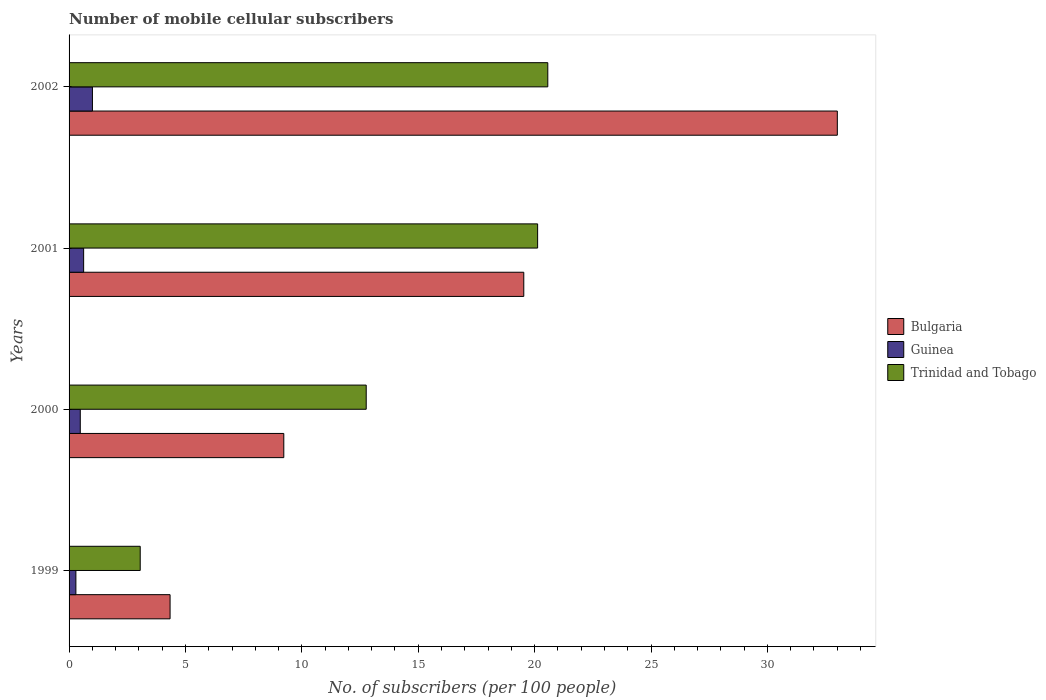How many different coloured bars are there?
Ensure brevity in your answer.  3. How many bars are there on the 3rd tick from the top?
Your answer should be very brief. 3. How many bars are there on the 4th tick from the bottom?
Provide a short and direct response. 3. In how many cases, is the number of bars for a given year not equal to the number of legend labels?
Your answer should be compact. 0. What is the number of mobile cellular subscribers in Bulgaria in 2000?
Provide a short and direct response. 9.22. Across all years, what is the maximum number of mobile cellular subscribers in Guinea?
Offer a terse response. 1. Across all years, what is the minimum number of mobile cellular subscribers in Guinea?
Your answer should be very brief. 0.29. What is the total number of mobile cellular subscribers in Guinea in the graph?
Give a very brief answer. 2.4. What is the difference between the number of mobile cellular subscribers in Trinidad and Tobago in 2000 and that in 2001?
Provide a short and direct response. -7.36. What is the difference between the number of mobile cellular subscribers in Trinidad and Tobago in 2001 and the number of mobile cellular subscribers in Bulgaria in 2002?
Your answer should be compact. -12.88. What is the average number of mobile cellular subscribers in Trinidad and Tobago per year?
Keep it short and to the point. 14.13. In the year 2002, what is the difference between the number of mobile cellular subscribers in Guinea and number of mobile cellular subscribers in Trinidad and Tobago?
Provide a succinct answer. -19.56. What is the ratio of the number of mobile cellular subscribers in Trinidad and Tobago in 1999 to that in 2002?
Provide a succinct answer. 0.15. What is the difference between the highest and the second highest number of mobile cellular subscribers in Guinea?
Provide a succinct answer. 0.38. What is the difference between the highest and the lowest number of mobile cellular subscribers in Trinidad and Tobago?
Make the answer very short. 17.51. In how many years, is the number of mobile cellular subscribers in Bulgaria greater than the average number of mobile cellular subscribers in Bulgaria taken over all years?
Keep it short and to the point. 2. What does the 2nd bar from the top in 2002 represents?
Make the answer very short. Guinea. What does the 2nd bar from the bottom in 2000 represents?
Make the answer very short. Guinea. Is it the case that in every year, the sum of the number of mobile cellular subscribers in Bulgaria and number of mobile cellular subscribers in Guinea is greater than the number of mobile cellular subscribers in Trinidad and Tobago?
Make the answer very short. No. How many bars are there?
Keep it short and to the point. 12. Are all the bars in the graph horizontal?
Your response must be concise. Yes. How many years are there in the graph?
Offer a very short reply. 4. What is the difference between two consecutive major ticks on the X-axis?
Keep it short and to the point. 5. Does the graph contain any zero values?
Your response must be concise. No. How many legend labels are there?
Your answer should be very brief. 3. How are the legend labels stacked?
Your answer should be very brief. Vertical. What is the title of the graph?
Make the answer very short. Number of mobile cellular subscribers. Does "Gabon" appear as one of the legend labels in the graph?
Offer a very short reply. No. What is the label or title of the X-axis?
Ensure brevity in your answer.  No. of subscribers (per 100 people). What is the label or title of the Y-axis?
Your answer should be compact. Years. What is the No. of subscribers (per 100 people) in Bulgaria in 1999?
Your answer should be compact. 4.34. What is the No. of subscribers (per 100 people) of Guinea in 1999?
Offer a very short reply. 0.29. What is the No. of subscribers (per 100 people) in Trinidad and Tobago in 1999?
Make the answer very short. 3.06. What is the No. of subscribers (per 100 people) of Bulgaria in 2000?
Your response must be concise. 9.22. What is the No. of subscribers (per 100 people) in Guinea in 2000?
Ensure brevity in your answer.  0.48. What is the No. of subscribers (per 100 people) in Trinidad and Tobago in 2000?
Make the answer very short. 12.77. What is the No. of subscribers (per 100 people) of Bulgaria in 2001?
Offer a terse response. 19.53. What is the No. of subscribers (per 100 people) in Guinea in 2001?
Provide a succinct answer. 0.63. What is the No. of subscribers (per 100 people) in Trinidad and Tobago in 2001?
Give a very brief answer. 20.13. What is the No. of subscribers (per 100 people) of Bulgaria in 2002?
Provide a succinct answer. 33. What is the No. of subscribers (per 100 people) of Guinea in 2002?
Provide a short and direct response. 1. What is the No. of subscribers (per 100 people) in Trinidad and Tobago in 2002?
Offer a terse response. 20.57. Across all years, what is the maximum No. of subscribers (per 100 people) of Bulgaria?
Ensure brevity in your answer.  33. Across all years, what is the maximum No. of subscribers (per 100 people) in Guinea?
Ensure brevity in your answer.  1. Across all years, what is the maximum No. of subscribers (per 100 people) in Trinidad and Tobago?
Your answer should be very brief. 20.57. Across all years, what is the minimum No. of subscribers (per 100 people) of Bulgaria?
Provide a succinct answer. 4.34. Across all years, what is the minimum No. of subscribers (per 100 people) in Guinea?
Provide a succinct answer. 0.29. Across all years, what is the minimum No. of subscribers (per 100 people) in Trinidad and Tobago?
Provide a succinct answer. 3.06. What is the total No. of subscribers (per 100 people) in Bulgaria in the graph?
Make the answer very short. 66.1. What is the total No. of subscribers (per 100 people) in Guinea in the graph?
Ensure brevity in your answer.  2.4. What is the total No. of subscribers (per 100 people) in Trinidad and Tobago in the graph?
Your answer should be compact. 56.52. What is the difference between the No. of subscribers (per 100 people) of Bulgaria in 1999 and that in 2000?
Give a very brief answer. -4.89. What is the difference between the No. of subscribers (per 100 people) in Guinea in 1999 and that in 2000?
Make the answer very short. -0.19. What is the difference between the No. of subscribers (per 100 people) in Trinidad and Tobago in 1999 and that in 2000?
Ensure brevity in your answer.  -9.71. What is the difference between the No. of subscribers (per 100 people) in Bulgaria in 1999 and that in 2001?
Your answer should be very brief. -15.19. What is the difference between the No. of subscribers (per 100 people) in Guinea in 1999 and that in 2001?
Provide a short and direct response. -0.33. What is the difference between the No. of subscribers (per 100 people) of Trinidad and Tobago in 1999 and that in 2001?
Offer a terse response. -17.07. What is the difference between the No. of subscribers (per 100 people) in Bulgaria in 1999 and that in 2002?
Make the answer very short. -28.66. What is the difference between the No. of subscribers (per 100 people) of Guinea in 1999 and that in 2002?
Keep it short and to the point. -0.71. What is the difference between the No. of subscribers (per 100 people) in Trinidad and Tobago in 1999 and that in 2002?
Offer a terse response. -17.51. What is the difference between the No. of subscribers (per 100 people) of Bulgaria in 2000 and that in 2001?
Provide a short and direct response. -10.31. What is the difference between the No. of subscribers (per 100 people) in Guinea in 2000 and that in 2001?
Provide a short and direct response. -0.14. What is the difference between the No. of subscribers (per 100 people) of Trinidad and Tobago in 2000 and that in 2001?
Give a very brief answer. -7.36. What is the difference between the No. of subscribers (per 100 people) of Bulgaria in 2000 and that in 2002?
Provide a succinct answer. -23.78. What is the difference between the No. of subscribers (per 100 people) in Guinea in 2000 and that in 2002?
Offer a terse response. -0.52. What is the difference between the No. of subscribers (per 100 people) in Trinidad and Tobago in 2000 and that in 2002?
Your answer should be very brief. -7.8. What is the difference between the No. of subscribers (per 100 people) of Bulgaria in 2001 and that in 2002?
Offer a terse response. -13.47. What is the difference between the No. of subscribers (per 100 people) in Guinea in 2001 and that in 2002?
Give a very brief answer. -0.38. What is the difference between the No. of subscribers (per 100 people) of Trinidad and Tobago in 2001 and that in 2002?
Provide a short and direct response. -0.44. What is the difference between the No. of subscribers (per 100 people) of Bulgaria in 1999 and the No. of subscribers (per 100 people) of Guinea in 2000?
Keep it short and to the point. 3.86. What is the difference between the No. of subscribers (per 100 people) in Bulgaria in 1999 and the No. of subscribers (per 100 people) in Trinidad and Tobago in 2000?
Offer a very short reply. -8.43. What is the difference between the No. of subscribers (per 100 people) of Guinea in 1999 and the No. of subscribers (per 100 people) of Trinidad and Tobago in 2000?
Keep it short and to the point. -12.47. What is the difference between the No. of subscribers (per 100 people) in Bulgaria in 1999 and the No. of subscribers (per 100 people) in Guinea in 2001?
Offer a terse response. 3.71. What is the difference between the No. of subscribers (per 100 people) of Bulgaria in 1999 and the No. of subscribers (per 100 people) of Trinidad and Tobago in 2001?
Ensure brevity in your answer.  -15.79. What is the difference between the No. of subscribers (per 100 people) in Guinea in 1999 and the No. of subscribers (per 100 people) in Trinidad and Tobago in 2001?
Your answer should be compact. -19.84. What is the difference between the No. of subscribers (per 100 people) in Bulgaria in 1999 and the No. of subscribers (per 100 people) in Guinea in 2002?
Offer a terse response. 3.34. What is the difference between the No. of subscribers (per 100 people) of Bulgaria in 1999 and the No. of subscribers (per 100 people) of Trinidad and Tobago in 2002?
Your answer should be compact. -16.23. What is the difference between the No. of subscribers (per 100 people) in Guinea in 1999 and the No. of subscribers (per 100 people) in Trinidad and Tobago in 2002?
Make the answer very short. -20.27. What is the difference between the No. of subscribers (per 100 people) of Bulgaria in 2000 and the No. of subscribers (per 100 people) of Guinea in 2001?
Offer a very short reply. 8.6. What is the difference between the No. of subscribers (per 100 people) of Bulgaria in 2000 and the No. of subscribers (per 100 people) of Trinidad and Tobago in 2001?
Your answer should be very brief. -10.9. What is the difference between the No. of subscribers (per 100 people) in Guinea in 2000 and the No. of subscribers (per 100 people) in Trinidad and Tobago in 2001?
Give a very brief answer. -19.65. What is the difference between the No. of subscribers (per 100 people) in Bulgaria in 2000 and the No. of subscribers (per 100 people) in Guinea in 2002?
Provide a succinct answer. 8.22. What is the difference between the No. of subscribers (per 100 people) in Bulgaria in 2000 and the No. of subscribers (per 100 people) in Trinidad and Tobago in 2002?
Provide a short and direct response. -11.34. What is the difference between the No. of subscribers (per 100 people) in Guinea in 2000 and the No. of subscribers (per 100 people) in Trinidad and Tobago in 2002?
Offer a terse response. -20.08. What is the difference between the No. of subscribers (per 100 people) of Bulgaria in 2001 and the No. of subscribers (per 100 people) of Guinea in 2002?
Keep it short and to the point. 18.53. What is the difference between the No. of subscribers (per 100 people) of Bulgaria in 2001 and the No. of subscribers (per 100 people) of Trinidad and Tobago in 2002?
Your answer should be compact. -1.03. What is the difference between the No. of subscribers (per 100 people) of Guinea in 2001 and the No. of subscribers (per 100 people) of Trinidad and Tobago in 2002?
Make the answer very short. -19.94. What is the average No. of subscribers (per 100 people) of Bulgaria per year?
Keep it short and to the point. 16.53. What is the average No. of subscribers (per 100 people) in Guinea per year?
Offer a terse response. 0.6. What is the average No. of subscribers (per 100 people) of Trinidad and Tobago per year?
Your answer should be very brief. 14.13. In the year 1999, what is the difference between the No. of subscribers (per 100 people) of Bulgaria and No. of subscribers (per 100 people) of Guinea?
Ensure brevity in your answer.  4.05. In the year 1999, what is the difference between the No. of subscribers (per 100 people) in Bulgaria and No. of subscribers (per 100 people) in Trinidad and Tobago?
Give a very brief answer. 1.28. In the year 1999, what is the difference between the No. of subscribers (per 100 people) of Guinea and No. of subscribers (per 100 people) of Trinidad and Tobago?
Ensure brevity in your answer.  -2.76. In the year 2000, what is the difference between the No. of subscribers (per 100 people) of Bulgaria and No. of subscribers (per 100 people) of Guinea?
Your answer should be very brief. 8.74. In the year 2000, what is the difference between the No. of subscribers (per 100 people) of Bulgaria and No. of subscribers (per 100 people) of Trinidad and Tobago?
Your answer should be very brief. -3.54. In the year 2000, what is the difference between the No. of subscribers (per 100 people) of Guinea and No. of subscribers (per 100 people) of Trinidad and Tobago?
Offer a very short reply. -12.28. In the year 2001, what is the difference between the No. of subscribers (per 100 people) of Bulgaria and No. of subscribers (per 100 people) of Guinea?
Ensure brevity in your answer.  18.91. In the year 2001, what is the difference between the No. of subscribers (per 100 people) of Bulgaria and No. of subscribers (per 100 people) of Trinidad and Tobago?
Keep it short and to the point. -0.59. In the year 2001, what is the difference between the No. of subscribers (per 100 people) of Guinea and No. of subscribers (per 100 people) of Trinidad and Tobago?
Give a very brief answer. -19.5. In the year 2002, what is the difference between the No. of subscribers (per 100 people) in Bulgaria and No. of subscribers (per 100 people) in Guinea?
Provide a succinct answer. 32. In the year 2002, what is the difference between the No. of subscribers (per 100 people) in Bulgaria and No. of subscribers (per 100 people) in Trinidad and Tobago?
Provide a succinct answer. 12.44. In the year 2002, what is the difference between the No. of subscribers (per 100 people) of Guinea and No. of subscribers (per 100 people) of Trinidad and Tobago?
Give a very brief answer. -19.56. What is the ratio of the No. of subscribers (per 100 people) of Bulgaria in 1999 to that in 2000?
Offer a terse response. 0.47. What is the ratio of the No. of subscribers (per 100 people) in Guinea in 1999 to that in 2000?
Give a very brief answer. 0.61. What is the ratio of the No. of subscribers (per 100 people) of Trinidad and Tobago in 1999 to that in 2000?
Keep it short and to the point. 0.24. What is the ratio of the No. of subscribers (per 100 people) of Bulgaria in 1999 to that in 2001?
Provide a short and direct response. 0.22. What is the ratio of the No. of subscribers (per 100 people) in Guinea in 1999 to that in 2001?
Keep it short and to the point. 0.47. What is the ratio of the No. of subscribers (per 100 people) of Trinidad and Tobago in 1999 to that in 2001?
Offer a very short reply. 0.15. What is the ratio of the No. of subscribers (per 100 people) of Bulgaria in 1999 to that in 2002?
Make the answer very short. 0.13. What is the ratio of the No. of subscribers (per 100 people) of Guinea in 1999 to that in 2002?
Offer a terse response. 0.29. What is the ratio of the No. of subscribers (per 100 people) of Trinidad and Tobago in 1999 to that in 2002?
Give a very brief answer. 0.15. What is the ratio of the No. of subscribers (per 100 people) in Bulgaria in 2000 to that in 2001?
Ensure brevity in your answer.  0.47. What is the ratio of the No. of subscribers (per 100 people) in Guinea in 2000 to that in 2001?
Your answer should be very brief. 0.77. What is the ratio of the No. of subscribers (per 100 people) in Trinidad and Tobago in 2000 to that in 2001?
Ensure brevity in your answer.  0.63. What is the ratio of the No. of subscribers (per 100 people) in Bulgaria in 2000 to that in 2002?
Your answer should be very brief. 0.28. What is the ratio of the No. of subscribers (per 100 people) in Guinea in 2000 to that in 2002?
Your response must be concise. 0.48. What is the ratio of the No. of subscribers (per 100 people) in Trinidad and Tobago in 2000 to that in 2002?
Your answer should be compact. 0.62. What is the ratio of the No. of subscribers (per 100 people) of Bulgaria in 2001 to that in 2002?
Offer a very short reply. 0.59. What is the ratio of the No. of subscribers (per 100 people) in Guinea in 2001 to that in 2002?
Provide a short and direct response. 0.62. What is the ratio of the No. of subscribers (per 100 people) of Trinidad and Tobago in 2001 to that in 2002?
Offer a terse response. 0.98. What is the difference between the highest and the second highest No. of subscribers (per 100 people) in Bulgaria?
Offer a terse response. 13.47. What is the difference between the highest and the second highest No. of subscribers (per 100 people) in Guinea?
Provide a short and direct response. 0.38. What is the difference between the highest and the second highest No. of subscribers (per 100 people) of Trinidad and Tobago?
Offer a very short reply. 0.44. What is the difference between the highest and the lowest No. of subscribers (per 100 people) of Bulgaria?
Keep it short and to the point. 28.66. What is the difference between the highest and the lowest No. of subscribers (per 100 people) in Guinea?
Provide a succinct answer. 0.71. What is the difference between the highest and the lowest No. of subscribers (per 100 people) of Trinidad and Tobago?
Your answer should be compact. 17.51. 